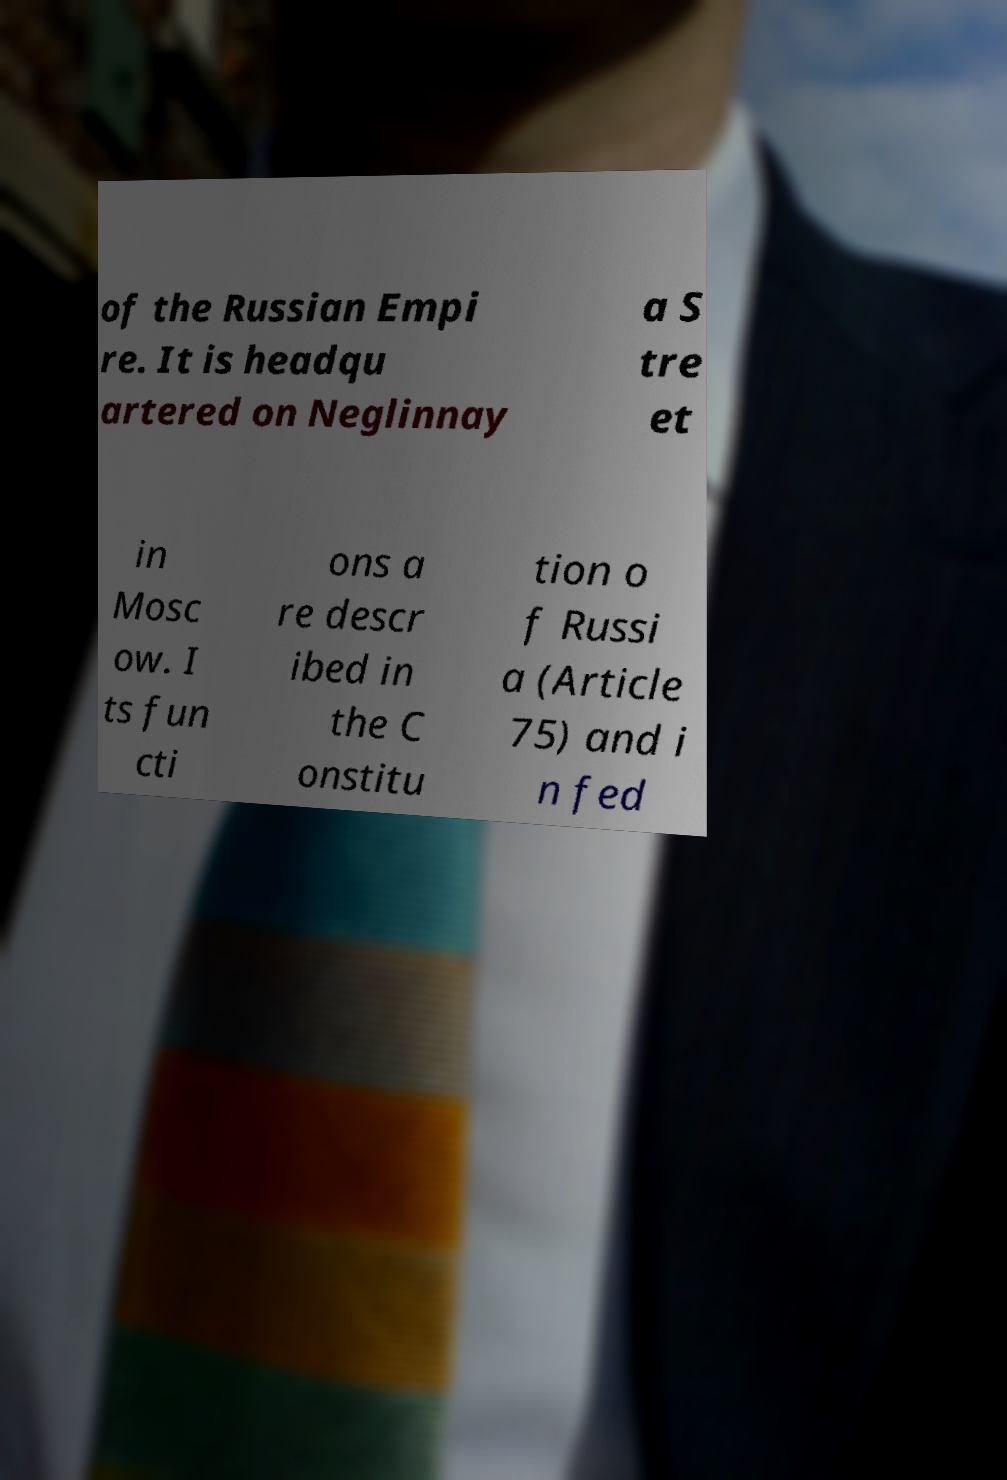Can you accurately transcribe the text from the provided image for me? of the Russian Empi re. It is headqu artered on Neglinnay a S tre et in Mosc ow. I ts fun cti ons a re descr ibed in the C onstitu tion o f Russi a (Article 75) and i n fed 